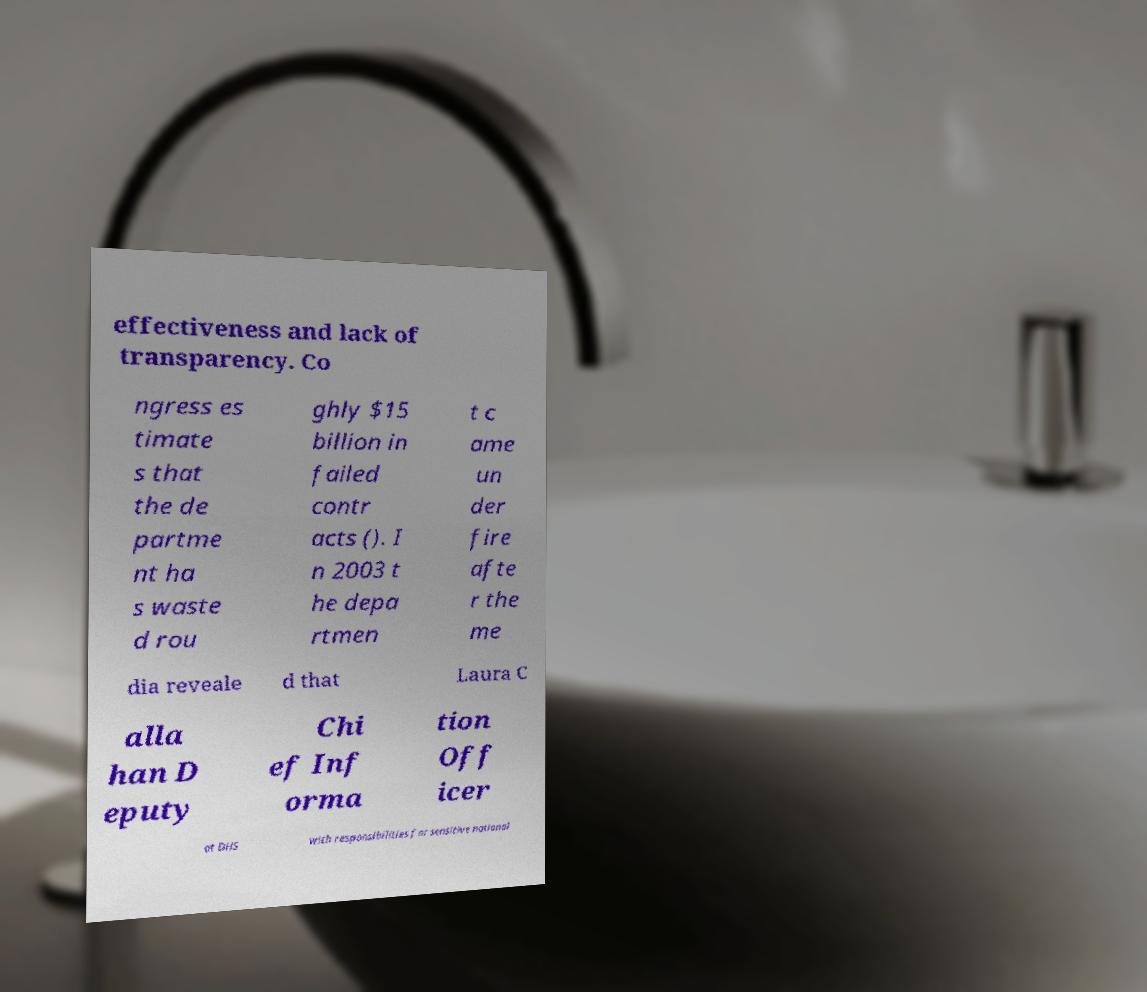Could you assist in decoding the text presented in this image and type it out clearly? effectiveness and lack of transparency. Co ngress es timate s that the de partme nt ha s waste d rou ghly $15 billion in failed contr acts (). I n 2003 t he depa rtmen t c ame un der fire afte r the me dia reveale d that Laura C alla han D eputy Chi ef Inf orma tion Off icer at DHS with responsibilities for sensitive national 